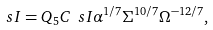Convert formula to latex. <formula><loc_0><loc_0><loc_500><loc_500>\ s I = Q _ { 5 } C _ { \ } s I \alpha ^ { 1 / 7 } \Sigma ^ { 1 0 / 7 } \Omega ^ { - 1 2 / 7 } ,</formula> 